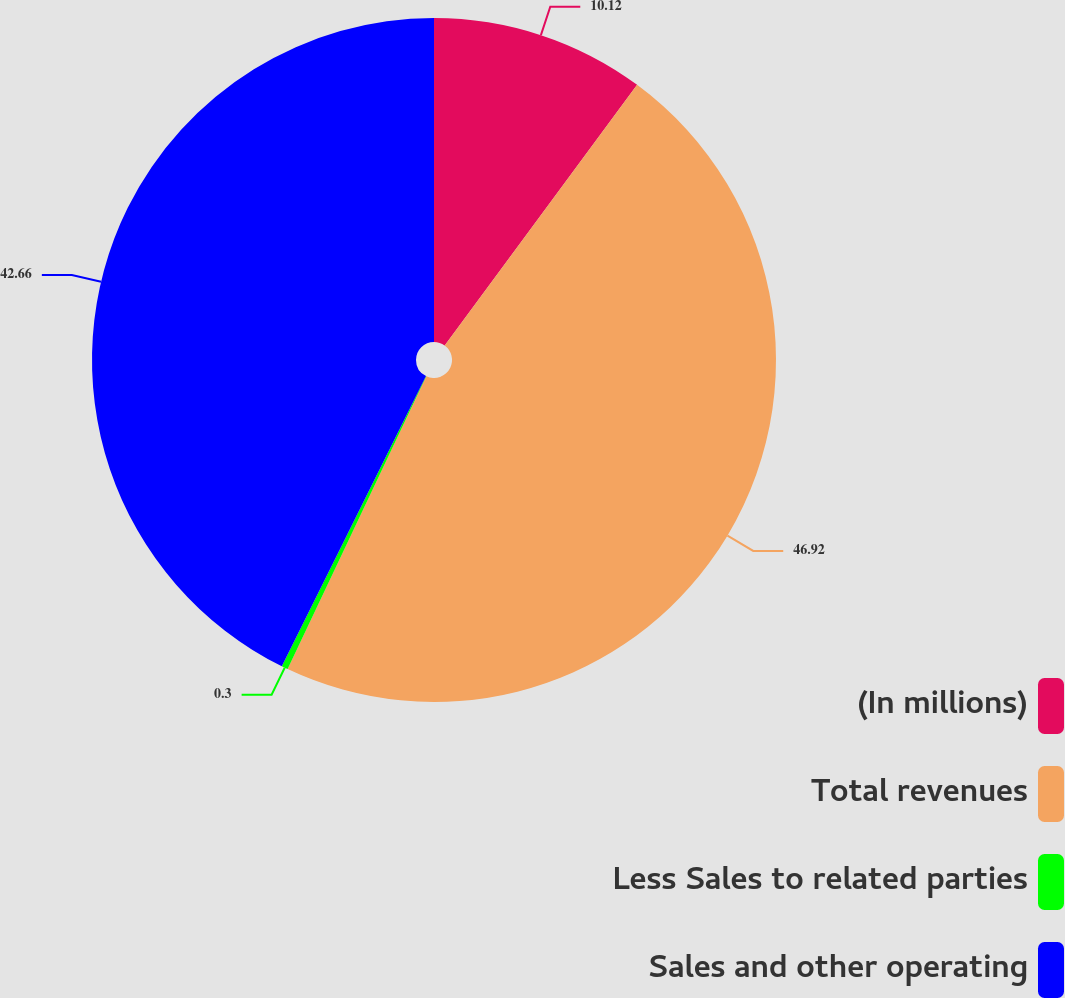Convert chart to OTSL. <chart><loc_0><loc_0><loc_500><loc_500><pie_chart><fcel>(In millions)<fcel>Total revenues<fcel>Less Sales to related parties<fcel>Sales and other operating<nl><fcel>10.12%<fcel>46.92%<fcel>0.3%<fcel>42.66%<nl></chart> 